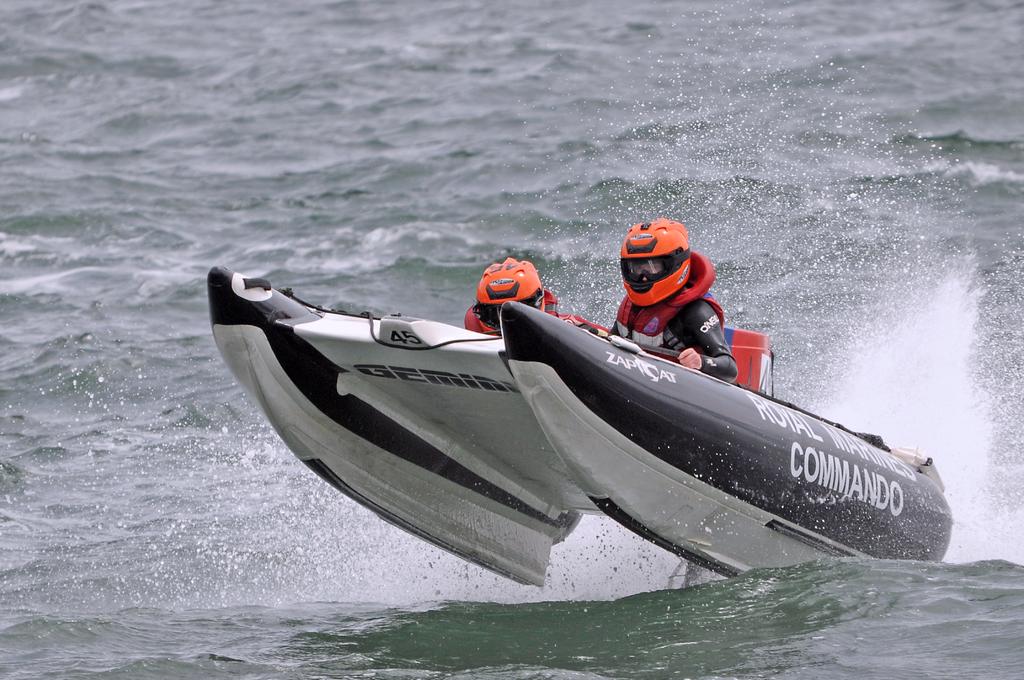What is one word emblazoned on this water vehicle?
Provide a short and direct response. Commando. 